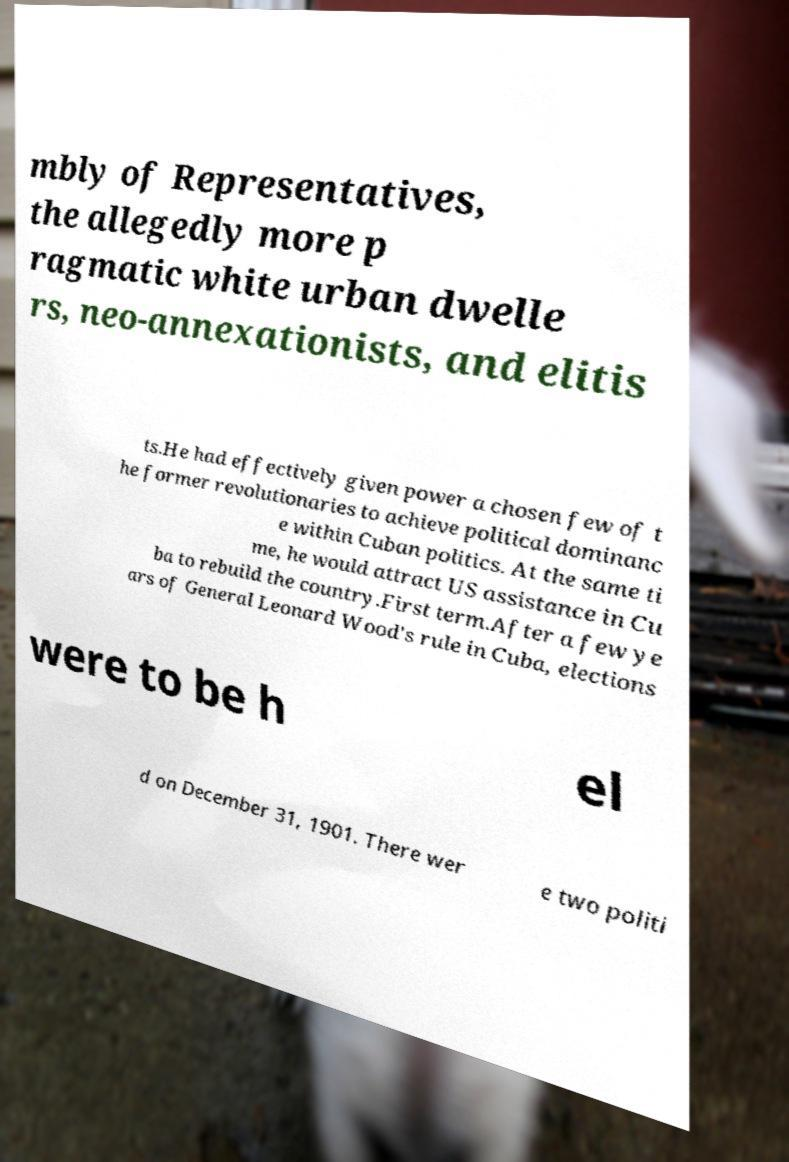For documentation purposes, I need the text within this image transcribed. Could you provide that? mbly of Representatives, the allegedly more p ragmatic white urban dwelle rs, neo-annexationists, and elitis ts.He had effectively given power a chosen few of t he former revolutionaries to achieve political dominanc e within Cuban politics. At the same ti me, he would attract US assistance in Cu ba to rebuild the country.First term.After a few ye ars of General Leonard Wood's rule in Cuba, elections were to be h el d on December 31, 1901. There wer e two politi 